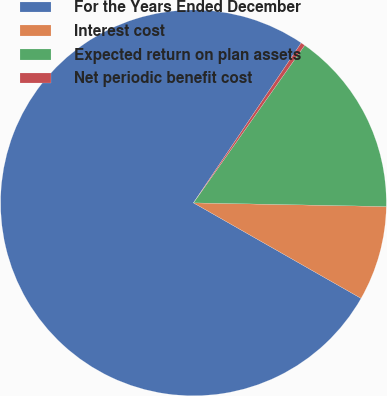Convert chart to OTSL. <chart><loc_0><loc_0><loc_500><loc_500><pie_chart><fcel>For the Years Ended December<fcel>Interest cost<fcel>Expected return on plan assets<fcel>Net periodic benefit cost<nl><fcel>76.19%<fcel>7.94%<fcel>15.52%<fcel>0.35%<nl></chart> 